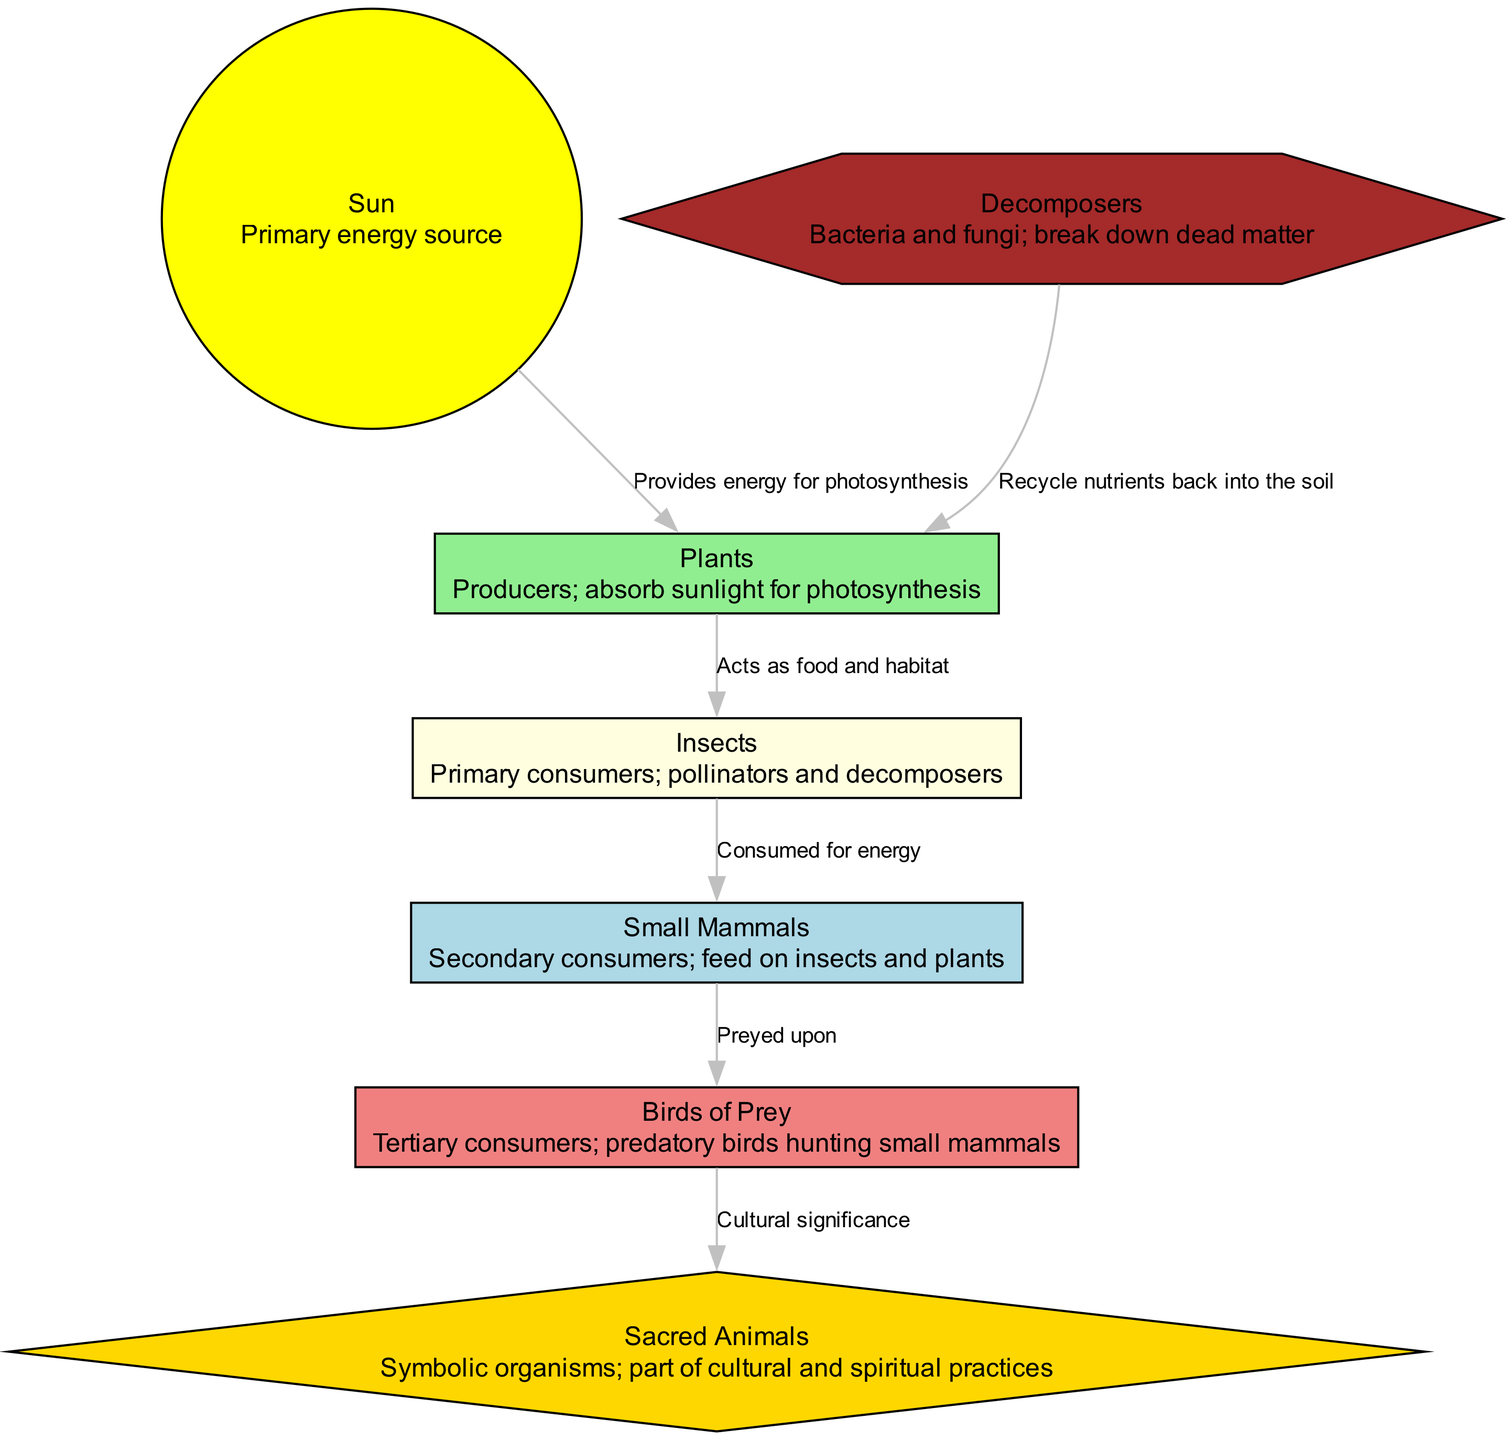What is the primary energy source in the diagram? The diagram identifies the Sun as the primary energy source for the ecosystem. This can be seen in the first node listing, which states that the Sun provides energy for photosynthesis.
Answer: Sun How many decomposers are in the food chain? The diagram lists only one decomposer type, which is "Decomposers." This can be found in the food chain array.
Answer: 1 What do plants provide to insects? According to the relationship in the diagram, plants act as food and habitat for insects. This is explicitly stated in the interaction label between these two nodes.
Answer: Food and habitat Which consumers are directly influenced by insects in the food chain? The food chain shows that insects are the primary consumers and are directly consumed by small mammals. This is confirmed by the edge connecting insects and small mammals.
Answer: Small Mammals What is the symbolic significance of sacred animals in relation to the birds of prey? The diagram indicates that the relationship between birds of prey and sacred animals is noted for its cultural significance. This relationship highlights the importance of sacred animals in tribal culture as per the interaction label.
Answer: Cultural significance How do decomposers contribute to the food chain? The role of decomposers in the food chain is to recycle nutrients back into the soil. This is indicated in the relationship label connecting decomposers and plants.
Answer: Recycle nutrients In what way do birds of prey fit into the food chain? The diagram categorizes birds of prey as tertiary consumers that prey upon small mammals. This relationship highlights their role in the predator-prey dynamic.
Answer: Tertiary consumers What interaction occurs between small mammals and birds of prey? The relationship defined between small mammals and birds of prey shows that small mammals are preyed upon by these birds. This can be gathered by examining the interaction label on their connecting edge.
Answer: Preyed upon 